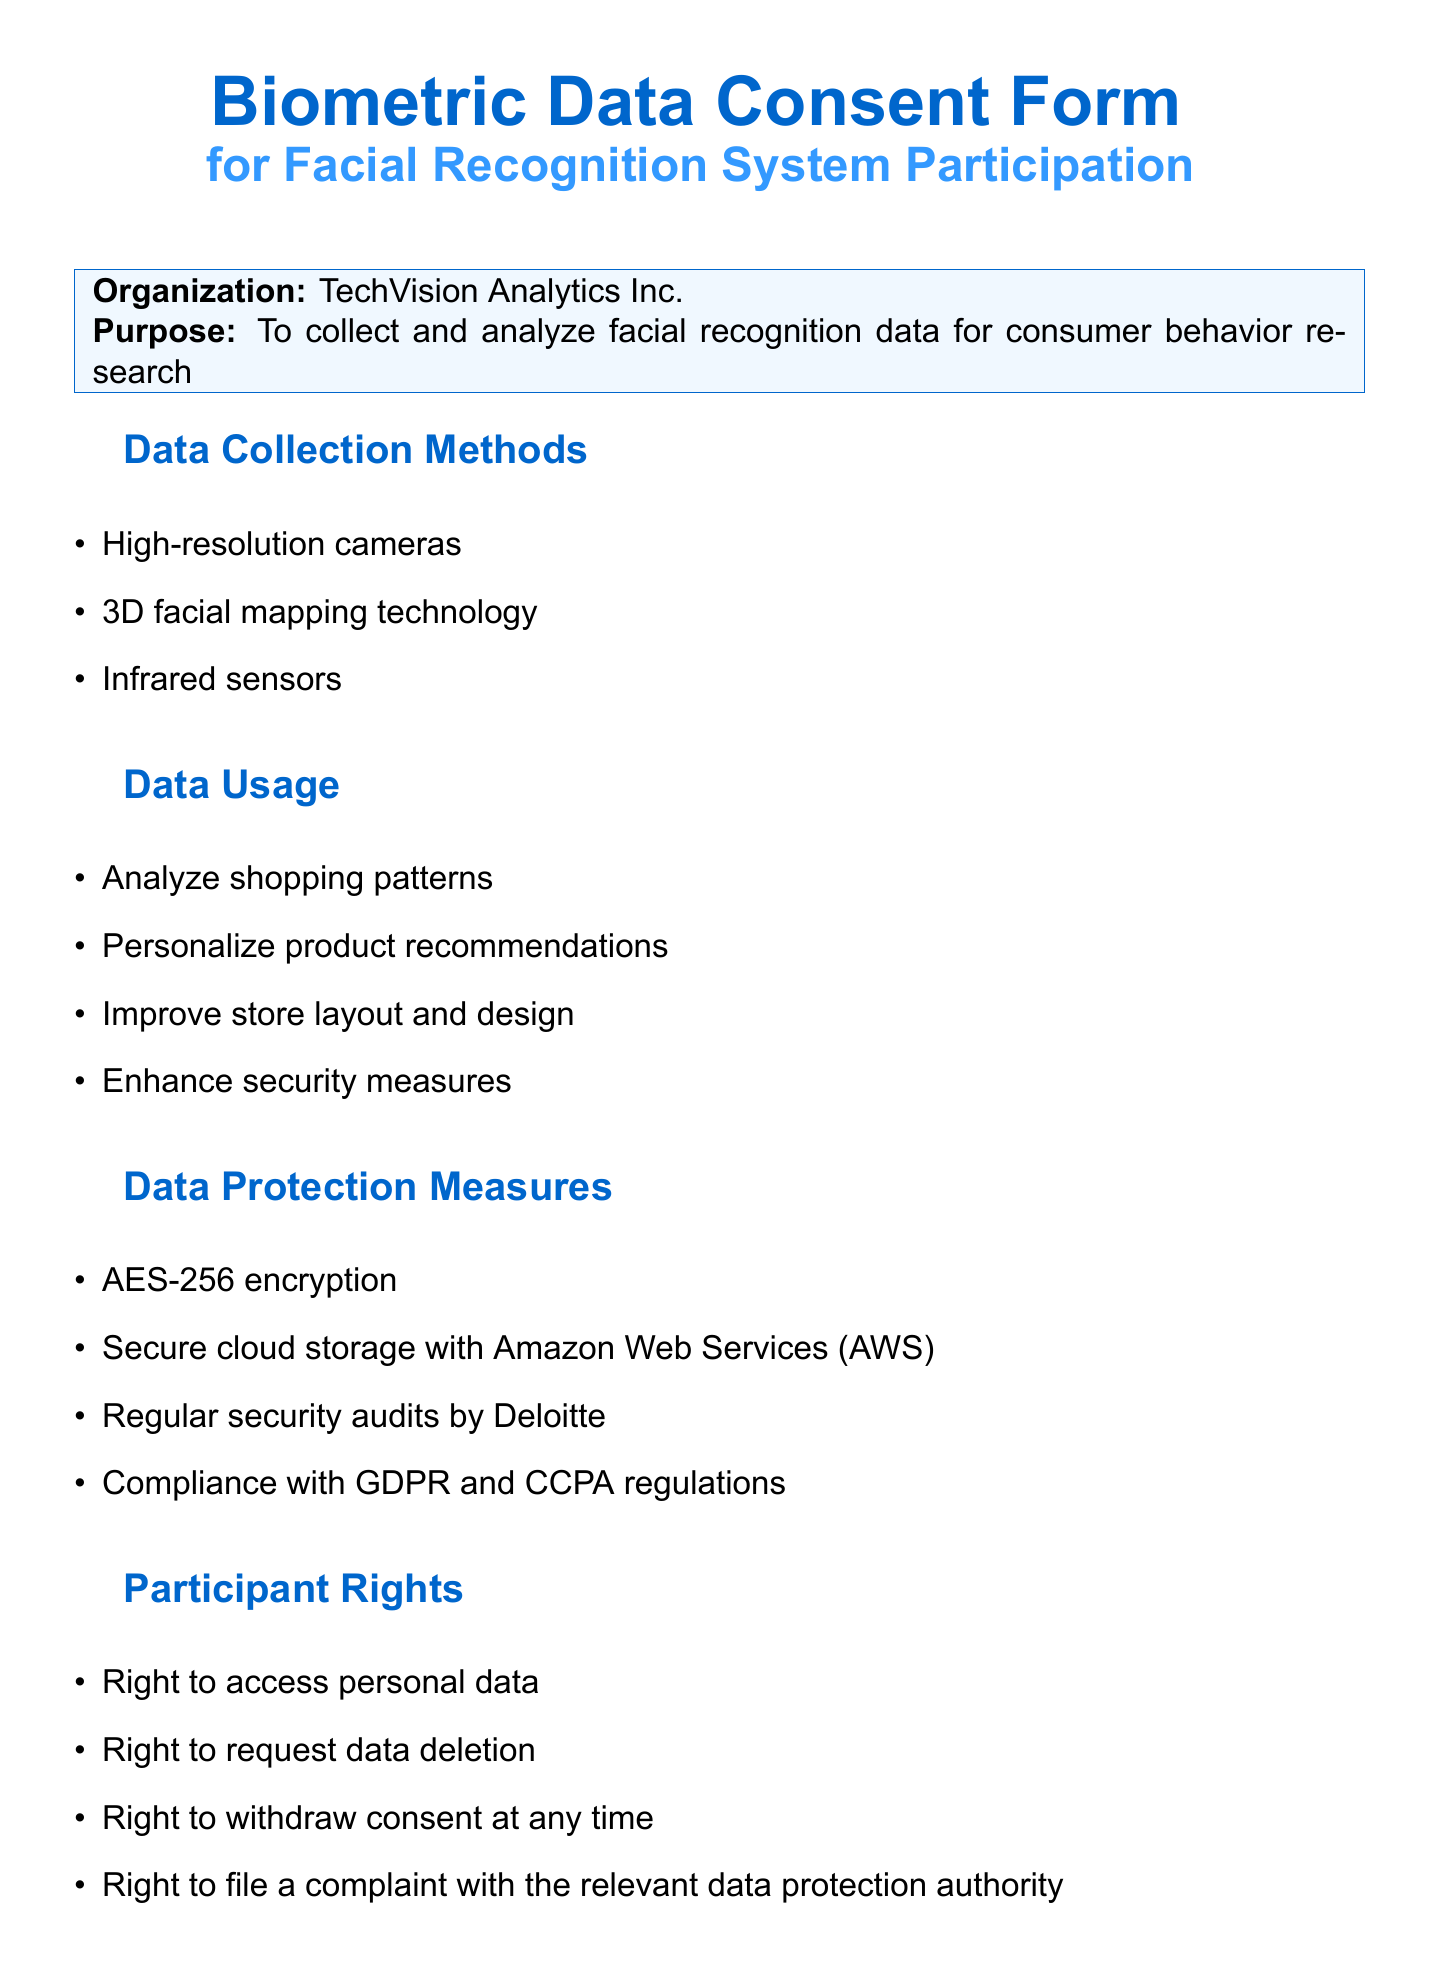What is the organization name? The organization name is listed in the document as the entity collecting the data.
Answer: TechVision Analytics Inc What is the retention period of the data? The retention period specifies how long the collected data will be stored.
Answer: 36 months from the date of collection Who is the data protection officer? The document provides the name of the person responsible for data protection matters.
Answer: Sarah Johnson What technology is used for data collection? The document lists the methods used for collecting biometric data.
Answer: High-resolution cameras What is one of the benefits of participation? Benefits are stated in the document as advantages for participants.
Answer: Personalized shopping experiences What is the purpose of sharing data with RetailInsights Co.? The document specifies the reason for sharing data with a third party.
Answer: Aggregate trend analysis What are participants entitled to regarding their data? Participants' rights are mentioned in the document to inform them of their control over personal data.
Answer: Right to access personal data What is one potential risk associated with data collection? Risks are listed in the document to inform participants about potential issues with their data.
Answer: Data breach What will happen if a participant decides to withdraw consent? The document informs participants about their ability to change their consent choice.
Answer: No penalty 